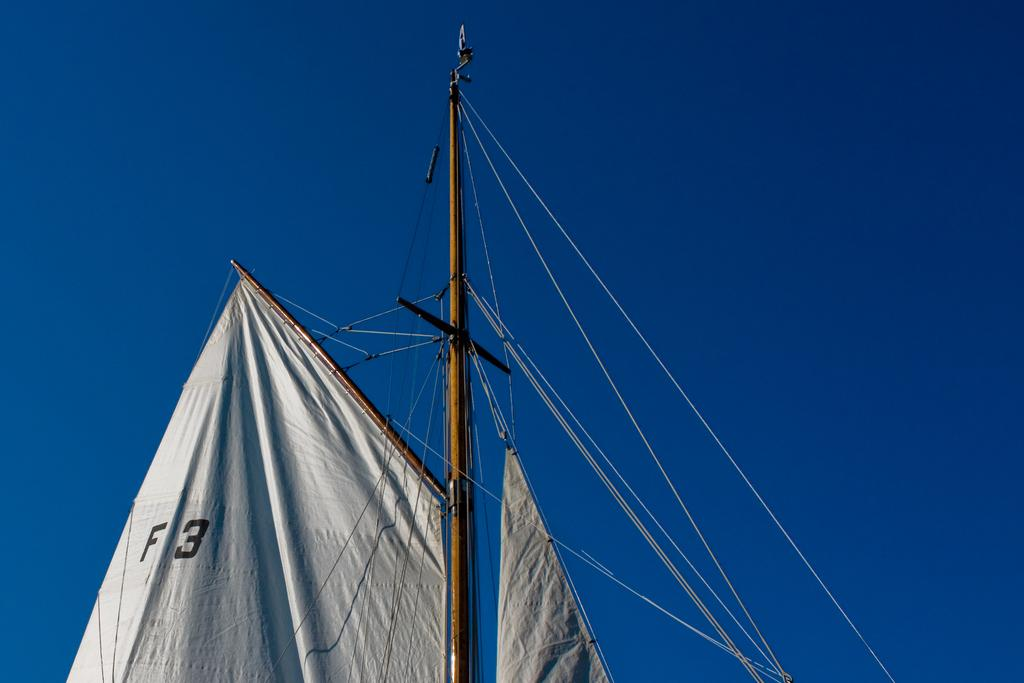Provide a one-sentence caption for the provided image. White sail which says F3 hanging in the air. 